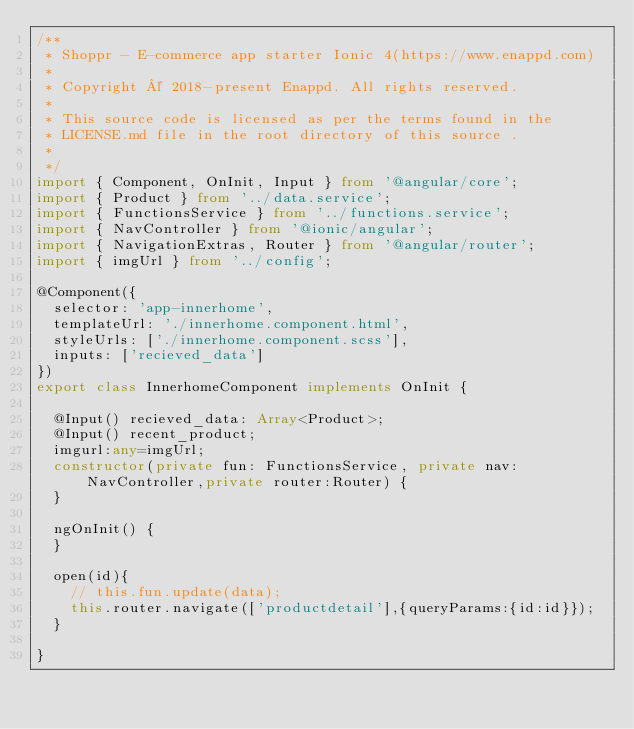Convert code to text. <code><loc_0><loc_0><loc_500><loc_500><_TypeScript_>/**
 * Shoppr - E-commerce app starter Ionic 4(https://www.enappd.com)
 *
 * Copyright © 2018-present Enappd. All rights reserved.
 *
 * This source code is licensed as per the terms found in the
 * LICENSE.md file in the root directory of this source .
 * 
 */
import { Component, OnInit, Input } from '@angular/core';
import { Product } from '../data.service';
import { FunctionsService } from '../functions.service';
import { NavController } from '@ionic/angular';
import { NavigationExtras, Router } from '@angular/router';
import { imgUrl } from '../config';

@Component({
  selector: 'app-innerhome',
  templateUrl: './innerhome.component.html',
  styleUrls: ['./innerhome.component.scss'],
  inputs: ['recieved_data']
})
export class InnerhomeComponent implements OnInit {

  @Input() recieved_data: Array<Product>;
  @Input() recent_product;
  imgurl:any=imgUrl;
  constructor(private fun: FunctionsService, private nav: NavController,private router:Router) {
  }

  ngOnInit() {
  }

  open(id){
    // this.fun.update(data);
    this.router.navigate(['productdetail'],{queryParams:{id:id}});
  }

}
</code> 